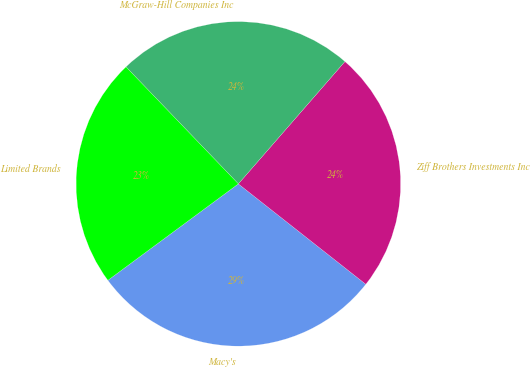Convert chart. <chart><loc_0><loc_0><loc_500><loc_500><pie_chart><fcel>Macy's<fcel>Ziff Brothers Investments Inc<fcel>McGraw-Hill Companies Inc<fcel>Limited Brands<nl><fcel>29.25%<fcel>24.21%<fcel>23.58%<fcel>22.95%<nl></chart> 